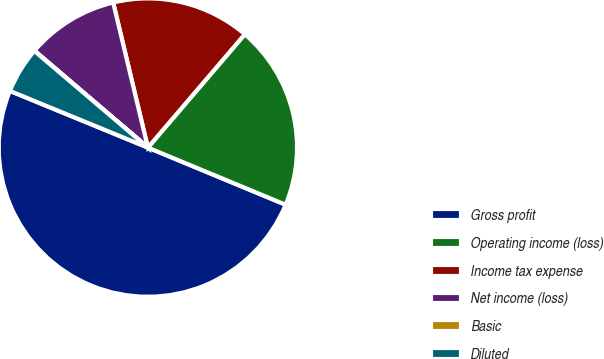Convert chart to OTSL. <chart><loc_0><loc_0><loc_500><loc_500><pie_chart><fcel>Gross profit<fcel>Operating income (loss)<fcel>Income tax expense<fcel>Net income (loss)<fcel>Basic<fcel>Diluted<nl><fcel>49.95%<fcel>20.0%<fcel>15.0%<fcel>10.01%<fcel>0.03%<fcel>5.02%<nl></chart> 